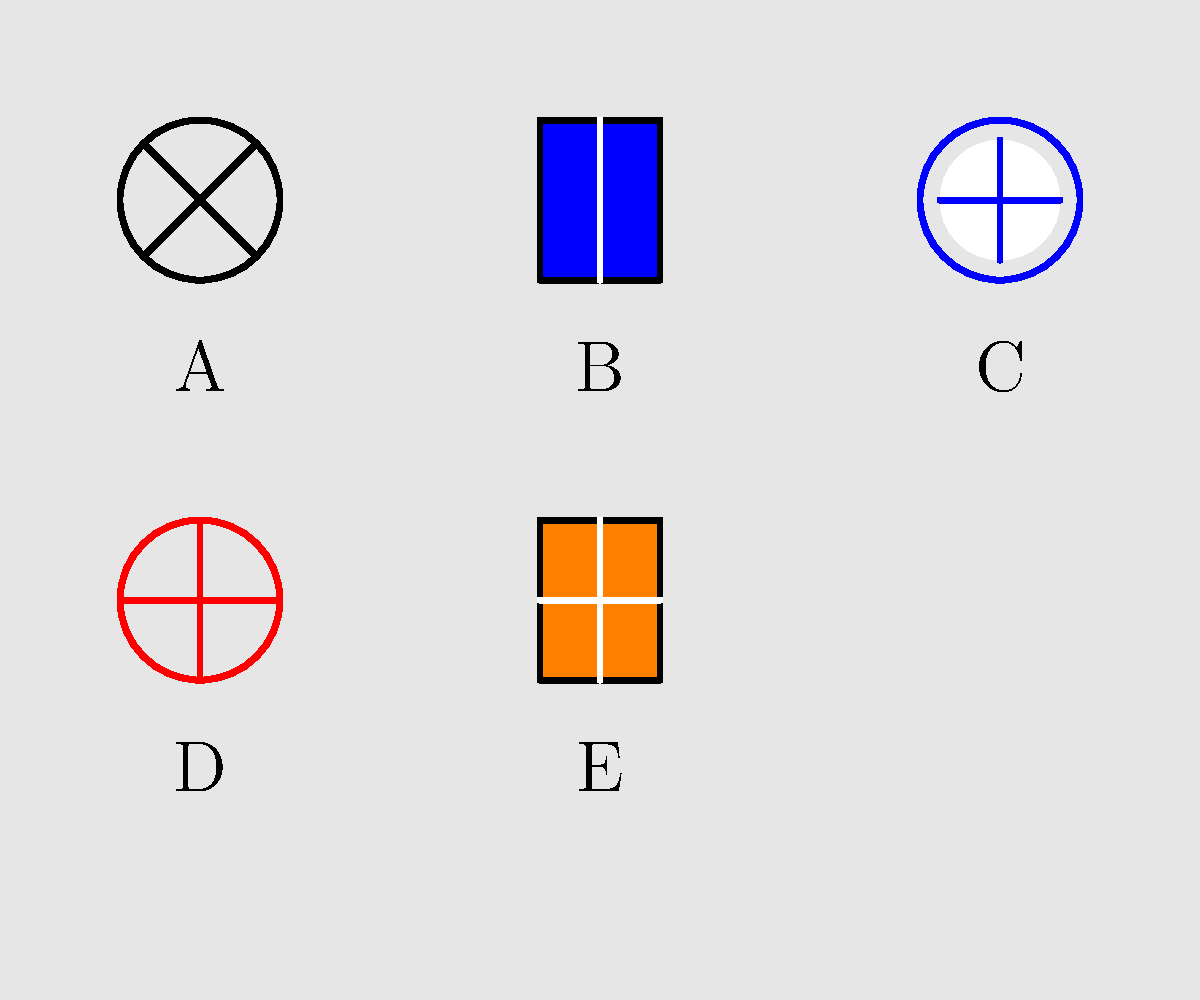Match the military insignia shown above to their corresponding branches of the U.S. Armed Forces. Which letter represents the insignia of the U.S. Marine Corps? To answer this question, let's analyze each insignia:

1. Insignia A: This shows a five-pointed star, which is the symbol for the U.S. Army.

2. Insignia B: This is a square-shaped insignia with vertical lines, representing the U.S. Navy.

3. Insignia C: This shows a circle with inner lines forming a star-like shape, which is the symbol for the U.S. Air Force.

4. Insignia D: This insignia features a globe, eagle, and anchor, which is the symbol for the U.S. Marine Corps.

5. Insignia E: This shows a shield-like shape, which represents the U.S. Coast Guard.

The question asks specifically about the U.S. Marine Corps insignia. From our analysis, we can see that this corresponds to letter D.
Answer: D 